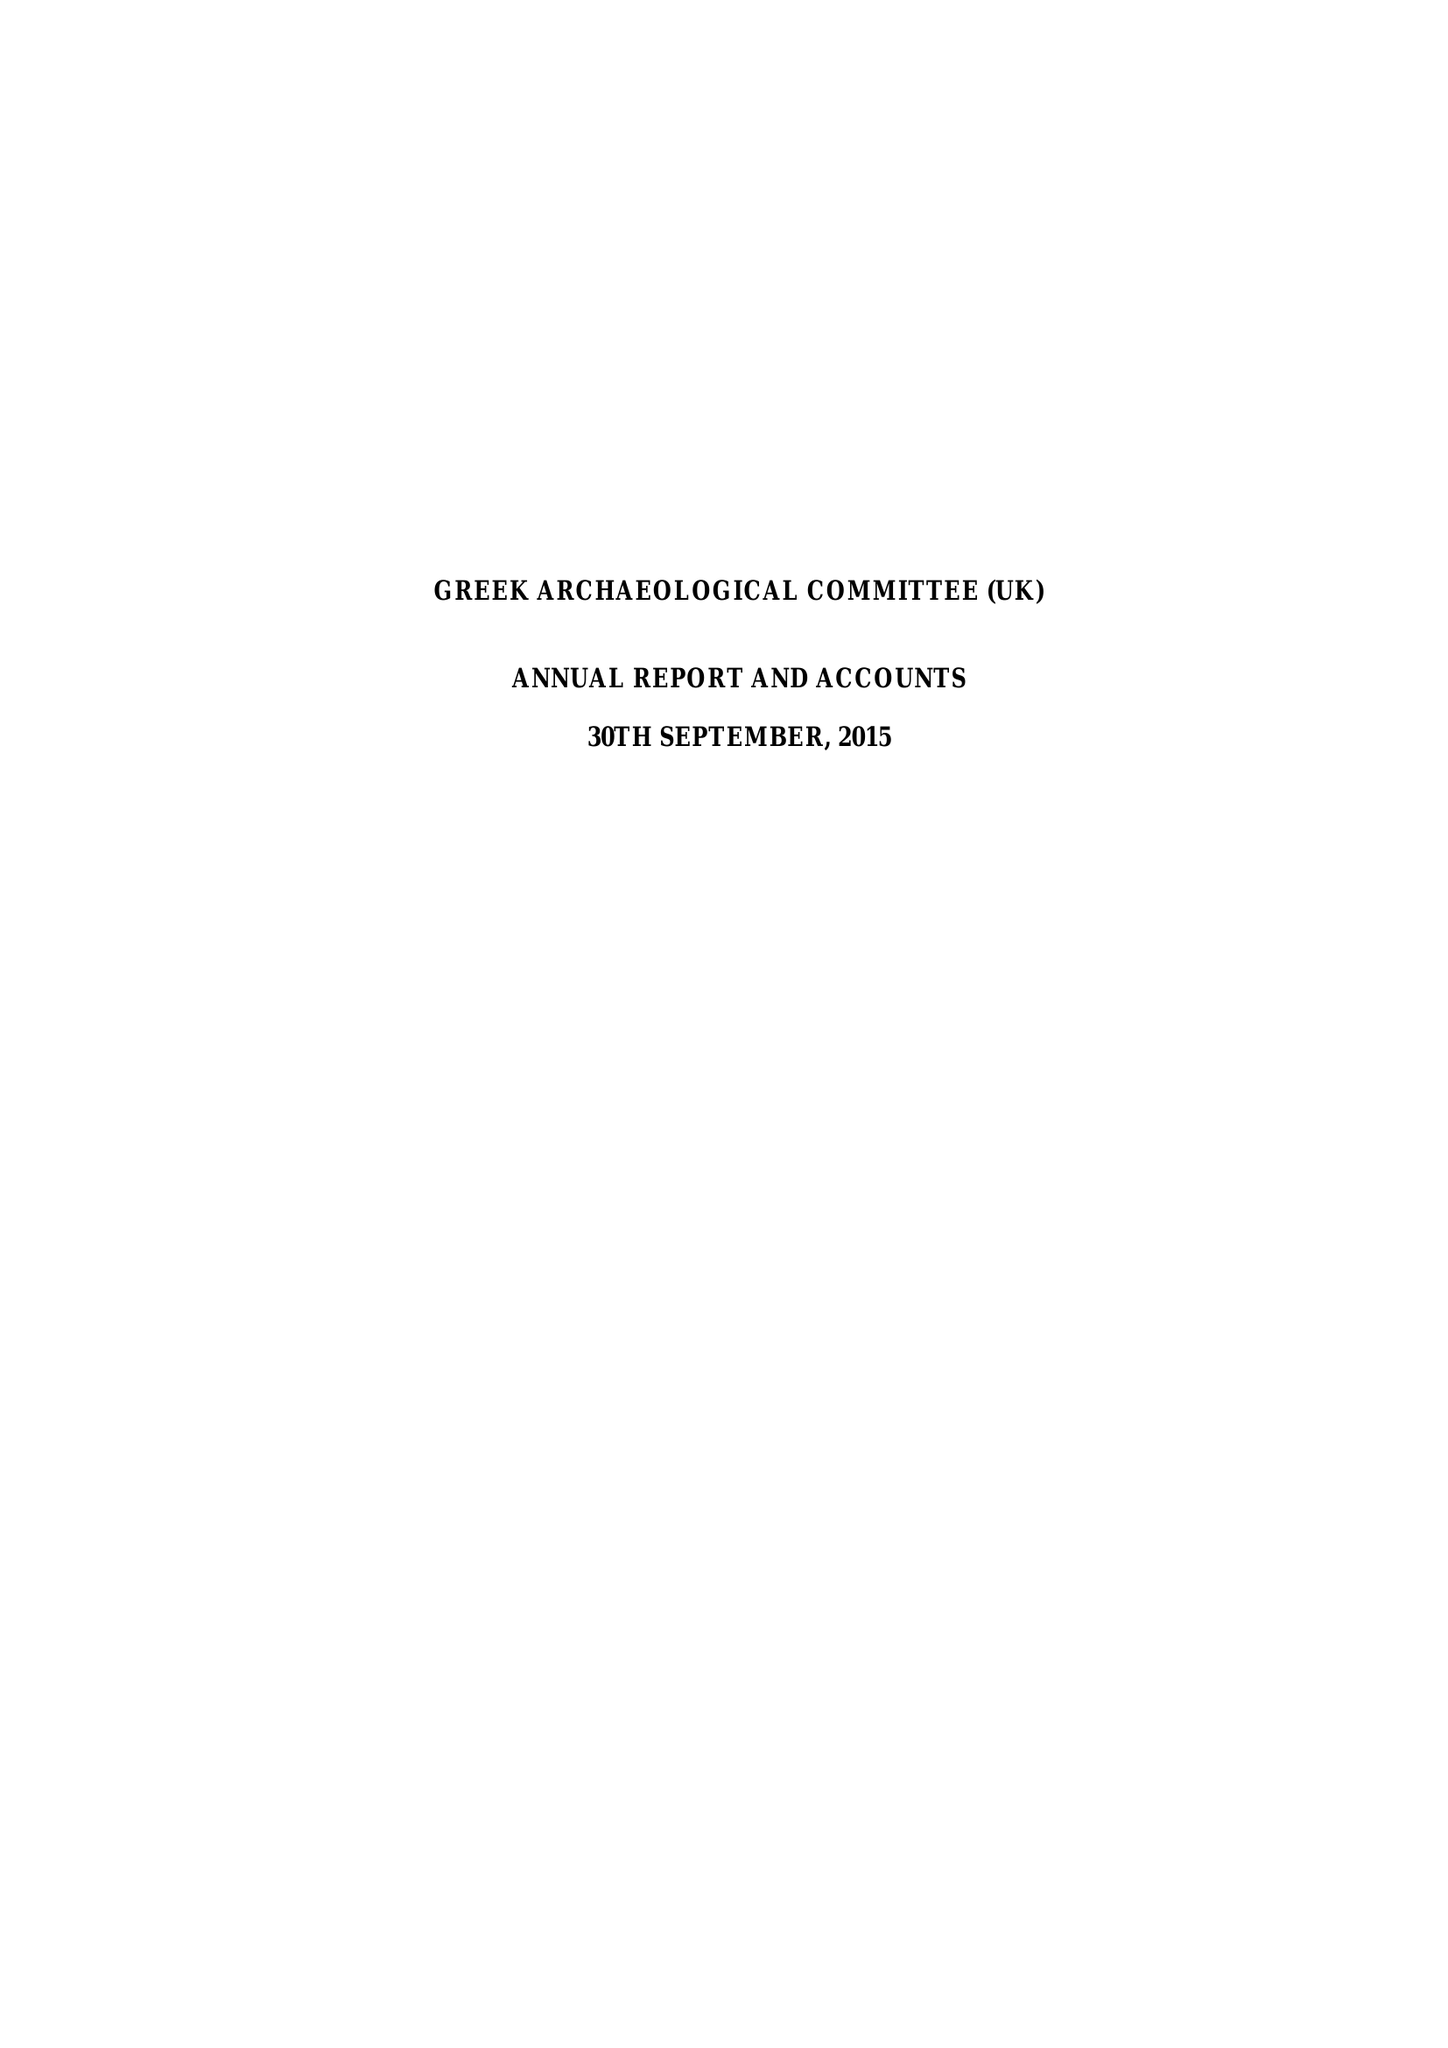What is the value for the income_annually_in_british_pounds?
Answer the question using a single word or phrase. 57390.00 